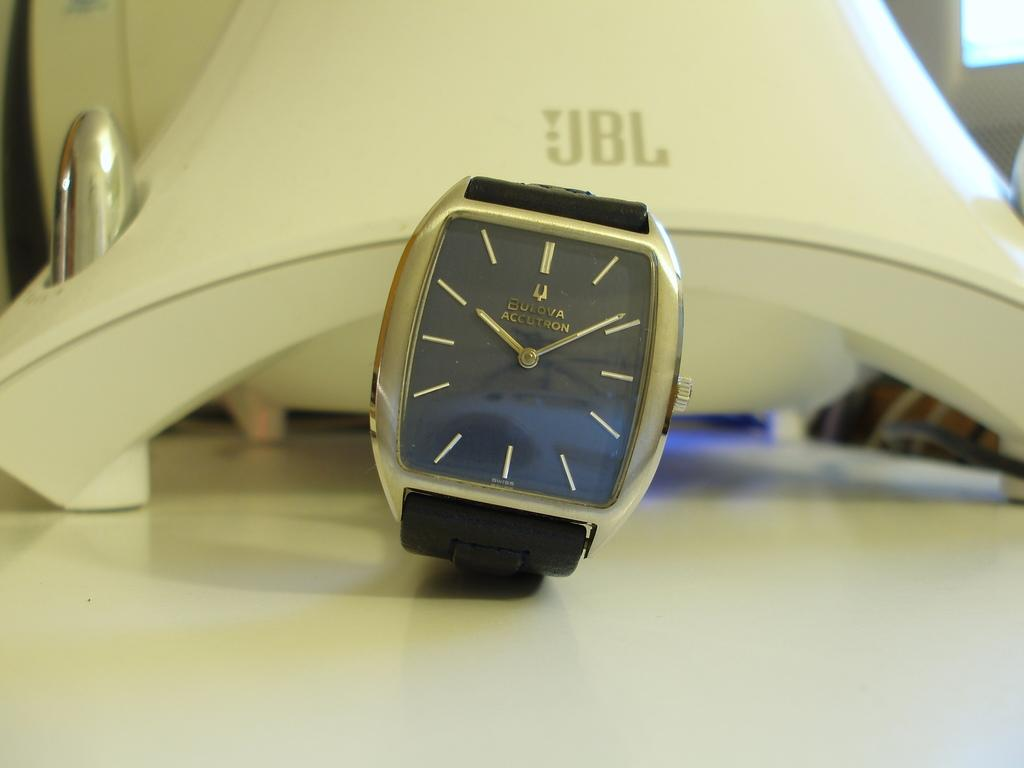<image>
Offer a succinct explanation of the picture presented. A black watch has "BULOVA ACCUTRON" on the face. 